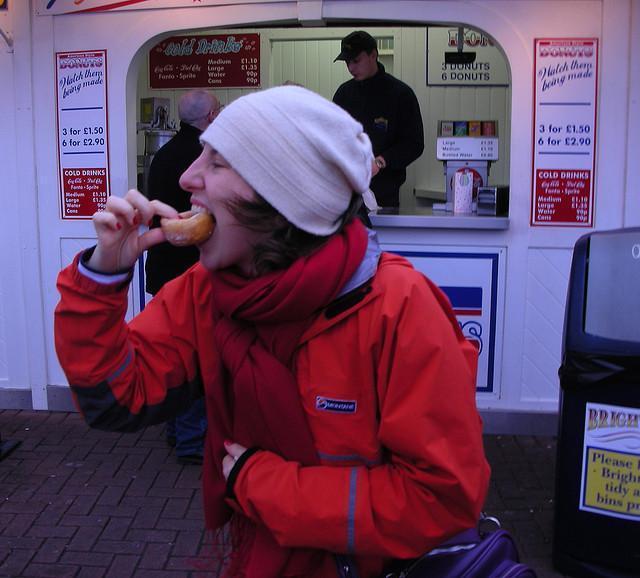How many caps in the picture?
Give a very brief answer. 2. How many people are in the background?
Give a very brief answer. 2. How many shirts is the woman wearing?
Give a very brief answer. 1. How many people are visible?
Give a very brief answer. 3. 